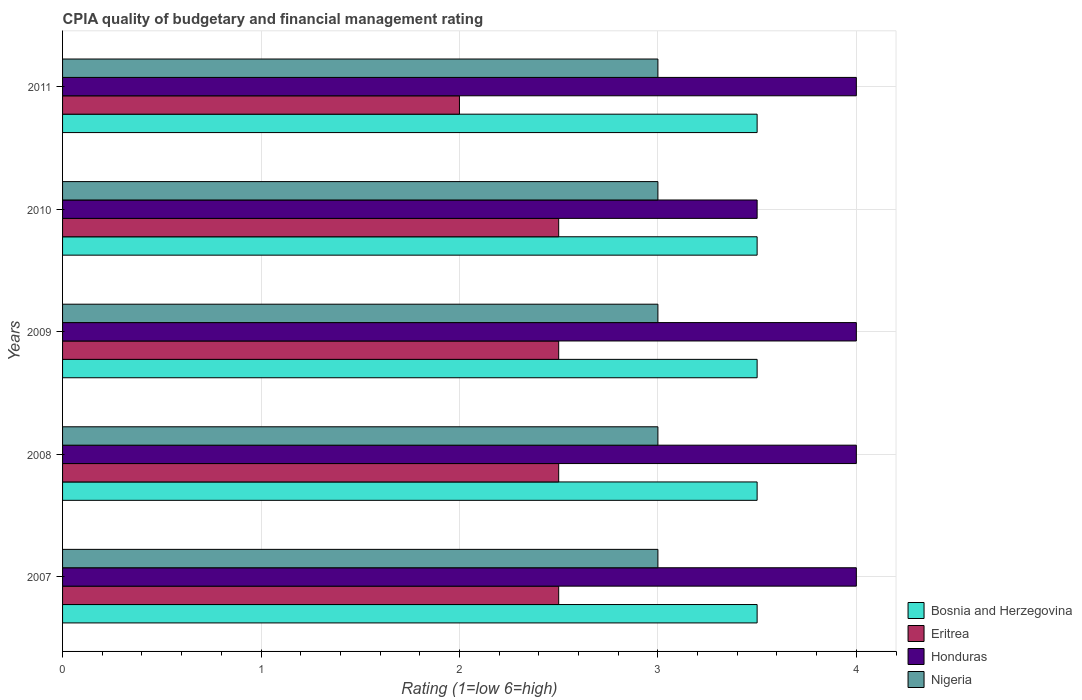Are the number of bars per tick equal to the number of legend labels?
Provide a succinct answer. Yes. How many bars are there on the 1st tick from the top?
Offer a terse response. 4. In how many cases, is the number of bars for a given year not equal to the number of legend labels?
Ensure brevity in your answer.  0. What is the CPIA rating in Honduras in 2007?
Keep it short and to the point. 4. Across all years, what is the maximum CPIA rating in Honduras?
Give a very brief answer. 4. What is the total CPIA rating in Honduras in the graph?
Keep it short and to the point. 19.5. What is the difference between the CPIA rating in Nigeria in 2009 and that in 2011?
Offer a very short reply. 0. What is the average CPIA rating in Nigeria per year?
Offer a terse response. 3. In the year 2008, what is the difference between the CPIA rating in Bosnia and Herzegovina and CPIA rating in Nigeria?
Your response must be concise. 0.5. What is the ratio of the CPIA rating in Bosnia and Herzegovina in 2007 to that in 2008?
Offer a very short reply. 1. Is the CPIA rating in Nigeria in 2007 less than that in 2008?
Make the answer very short. No. What is the difference between the highest and the second highest CPIA rating in Honduras?
Your response must be concise. 0. What is the difference between the highest and the lowest CPIA rating in Honduras?
Offer a very short reply. 0.5. In how many years, is the CPIA rating in Eritrea greater than the average CPIA rating in Eritrea taken over all years?
Offer a terse response. 4. What does the 4th bar from the top in 2011 represents?
Offer a very short reply. Bosnia and Herzegovina. What does the 4th bar from the bottom in 2007 represents?
Ensure brevity in your answer.  Nigeria. Is it the case that in every year, the sum of the CPIA rating in Eritrea and CPIA rating in Bosnia and Herzegovina is greater than the CPIA rating in Nigeria?
Your answer should be very brief. Yes. How many bars are there?
Ensure brevity in your answer.  20. Are all the bars in the graph horizontal?
Your answer should be very brief. Yes. How many years are there in the graph?
Your response must be concise. 5. What is the difference between two consecutive major ticks on the X-axis?
Ensure brevity in your answer.  1. How many legend labels are there?
Offer a very short reply. 4. How are the legend labels stacked?
Your answer should be compact. Vertical. What is the title of the graph?
Make the answer very short. CPIA quality of budgetary and financial management rating. What is the Rating (1=low 6=high) in Bosnia and Herzegovina in 2007?
Ensure brevity in your answer.  3.5. What is the Rating (1=low 6=high) in Eritrea in 2007?
Keep it short and to the point. 2.5. What is the Rating (1=low 6=high) in Nigeria in 2008?
Provide a succinct answer. 3. What is the Rating (1=low 6=high) of Bosnia and Herzegovina in 2009?
Keep it short and to the point. 3.5. What is the Rating (1=low 6=high) of Eritrea in 2009?
Give a very brief answer. 2.5. What is the Rating (1=low 6=high) of Honduras in 2009?
Make the answer very short. 4. What is the Rating (1=low 6=high) in Nigeria in 2009?
Your response must be concise. 3. What is the Rating (1=low 6=high) of Honduras in 2010?
Make the answer very short. 3.5. What is the Rating (1=low 6=high) of Nigeria in 2010?
Offer a terse response. 3. What is the Rating (1=low 6=high) of Honduras in 2011?
Your answer should be very brief. 4. What is the Rating (1=low 6=high) of Nigeria in 2011?
Offer a very short reply. 3. Across all years, what is the maximum Rating (1=low 6=high) in Nigeria?
Provide a succinct answer. 3. Across all years, what is the minimum Rating (1=low 6=high) of Eritrea?
Your answer should be very brief. 2. Across all years, what is the minimum Rating (1=low 6=high) of Honduras?
Provide a succinct answer. 3.5. Across all years, what is the minimum Rating (1=low 6=high) of Nigeria?
Give a very brief answer. 3. What is the total Rating (1=low 6=high) in Bosnia and Herzegovina in the graph?
Your answer should be compact. 17.5. What is the difference between the Rating (1=low 6=high) in Bosnia and Herzegovina in 2007 and that in 2008?
Your response must be concise. 0. What is the difference between the Rating (1=low 6=high) in Eritrea in 2007 and that in 2008?
Your answer should be very brief. 0. What is the difference between the Rating (1=low 6=high) in Bosnia and Herzegovina in 2007 and that in 2009?
Offer a very short reply. 0. What is the difference between the Rating (1=low 6=high) of Eritrea in 2007 and that in 2009?
Your answer should be compact. 0. What is the difference between the Rating (1=low 6=high) of Honduras in 2007 and that in 2009?
Provide a succinct answer. 0. What is the difference between the Rating (1=low 6=high) of Nigeria in 2007 and that in 2009?
Your answer should be very brief. 0. What is the difference between the Rating (1=low 6=high) of Eritrea in 2007 and that in 2010?
Your answer should be very brief. 0. What is the difference between the Rating (1=low 6=high) in Honduras in 2007 and that in 2011?
Offer a very short reply. 0. What is the difference between the Rating (1=low 6=high) of Eritrea in 2008 and that in 2009?
Your answer should be compact. 0. What is the difference between the Rating (1=low 6=high) of Bosnia and Herzegovina in 2008 and that in 2010?
Provide a succinct answer. 0. What is the difference between the Rating (1=low 6=high) in Eritrea in 2008 and that in 2010?
Your response must be concise. 0. What is the difference between the Rating (1=low 6=high) of Bosnia and Herzegovina in 2008 and that in 2011?
Ensure brevity in your answer.  0. What is the difference between the Rating (1=low 6=high) in Honduras in 2008 and that in 2011?
Make the answer very short. 0. What is the difference between the Rating (1=low 6=high) in Nigeria in 2008 and that in 2011?
Your answer should be very brief. 0. What is the difference between the Rating (1=low 6=high) of Eritrea in 2009 and that in 2010?
Offer a terse response. 0. What is the difference between the Rating (1=low 6=high) of Bosnia and Herzegovina in 2009 and that in 2011?
Your answer should be very brief. 0. What is the difference between the Rating (1=low 6=high) in Bosnia and Herzegovina in 2010 and that in 2011?
Your response must be concise. 0. What is the difference between the Rating (1=low 6=high) in Eritrea in 2010 and that in 2011?
Keep it short and to the point. 0.5. What is the difference between the Rating (1=low 6=high) of Nigeria in 2010 and that in 2011?
Your answer should be very brief. 0. What is the difference between the Rating (1=low 6=high) of Bosnia and Herzegovina in 2007 and the Rating (1=low 6=high) of Honduras in 2008?
Offer a terse response. -0.5. What is the difference between the Rating (1=low 6=high) of Bosnia and Herzegovina in 2007 and the Rating (1=low 6=high) of Nigeria in 2008?
Your response must be concise. 0.5. What is the difference between the Rating (1=low 6=high) of Eritrea in 2007 and the Rating (1=low 6=high) of Honduras in 2008?
Ensure brevity in your answer.  -1.5. What is the difference between the Rating (1=low 6=high) of Eritrea in 2007 and the Rating (1=low 6=high) of Nigeria in 2008?
Provide a succinct answer. -0.5. What is the difference between the Rating (1=low 6=high) of Bosnia and Herzegovina in 2007 and the Rating (1=low 6=high) of Eritrea in 2009?
Give a very brief answer. 1. What is the difference between the Rating (1=low 6=high) in Bosnia and Herzegovina in 2007 and the Rating (1=low 6=high) in Honduras in 2009?
Provide a succinct answer. -0.5. What is the difference between the Rating (1=low 6=high) of Bosnia and Herzegovina in 2007 and the Rating (1=low 6=high) of Nigeria in 2009?
Your answer should be compact. 0.5. What is the difference between the Rating (1=low 6=high) of Eritrea in 2007 and the Rating (1=low 6=high) of Nigeria in 2009?
Give a very brief answer. -0.5. What is the difference between the Rating (1=low 6=high) of Honduras in 2007 and the Rating (1=low 6=high) of Nigeria in 2009?
Offer a terse response. 1. What is the difference between the Rating (1=low 6=high) of Bosnia and Herzegovina in 2007 and the Rating (1=low 6=high) of Nigeria in 2010?
Offer a terse response. 0.5. What is the difference between the Rating (1=low 6=high) of Eritrea in 2007 and the Rating (1=low 6=high) of Honduras in 2010?
Make the answer very short. -1. What is the difference between the Rating (1=low 6=high) in Eritrea in 2007 and the Rating (1=low 6=high) in Nigeria in 2010?
Offer a very short reply. -0.5. What is the difference between the Rating (1=low 6=high) in Bosnia and Herzegovina in 2007 and the Rating (1=low 6=high) in Honduras in 2011?
Provide a short and direct response. -0.5. What is the difference between the Rating (1=low 6=high) in Bosnia and Herzegovina in 2008 and the Rating (1=low 6=high) in Honduras in 2009?
Offer a terse response. -0.5. What is the difference between the Rating (1=low 6=high) in Bosnia and Herzegovina in 2008 and the Rating (1=low 6=high) in Nigeria in 2009?
Make the answer very short. 0.5. What is the difference between the Rating (1=low 6=high) in Eritrea in 2008 and the Rating (1=low 6=high) in Honduras in 2009?
Make the answer very short. -1.5. What is the difference between the Rating (1=low 6=high) in Bosnia and Herzegovina in 2008 and the Rating (1=low 6=high) in Honduras in 2010?
Keep it short and to the point. 0. What is the difference between the Rating (1=low 6=high) in Bosnia and Herzegovina in 2008 and the Rating (1=low 6=high) in Nigeria in 2010?
Your answer should be compact. 0.5. What is the difference between the Rating (1=low 6=high) of Eritrea in 2008 and the Rating (1=low 6=high) of Honduras in 2010?
Provide a short and direct response. -1. What is the difference between the Rating (1=low 6=high) in Bosnia and Herzegovina in 2009 and the Rating (1=low 6=high) in Eritrea in 2010?
Offer a very short reply. 1. What is the difference between the Rating (1=low 6=high) of Bosnia and Herzegovina in 2009 and the Rating (1=low 6=high) of Nigeria in 2010?
Keep it short and to the point. 0.5. What is the difference between the Rating (1=low 6=high) of Eritrea in 2009 and the Rating (1=low 6=high) of Honduras in 2010?
Ensure brevity in your answer.  -1. What is the difference between the Rating (1=low 6=high) of Eritrea in 2009 and the Rating (1=low 6=high) of Nigeria in 2010?
Make the answer very short. -0.5. What is the difference between the Rating (1=low 6=high) of Honduras in 2009 and the Rating (1=low 6=high) of Nigeria in 2010?
Provide a succinct answer. 1. What is the difference between the Rating (1=low 6=high) in Bosnia and Herzegovina in 2009 and the Rating (1=low 6=high) in Eritrea in 2011?
Offer a very short reply. 1.5. What is the difference between the Rating (1=low 6=high) in Bosnia and Herzegovina in 2009 and the Rating (1=low 6=high) in Nigeria in 2011?
Give a very brief answer. 0.5. What is the difference between the Rating (1=low 6=high) in Eritrea in 2009 and the Rating (1=low 6=high) in Honduras in 2011?
Keep it short and to the point. -1.5. What is the difference between the Rating (1=low 6=high) in Bosnia and Herzegovina in 2010 and the Rating (1=low 6=high) in Nigeria in 2011?
Your response must be concise. 0.5. What is the difference between the Rating (1=low 6=high) in Eritrea in 2010 and the Rating (1=low 6=high) in Honduras in 2011?
Your response must be concise. -1.5. What is the difference between the Rating (1=low 6=high) in Eritrea in 2010 and the Rating (1=low 6=high) in Nigeria in 2011?
Keep it short and to the point. -0.5. What is the average Rating (1=low 6=high) of Eritrea per year?
Give a very brief answer. 2.4. In the year 2007, what is the difference between the Rating (1=low 6=high) in Bosnia and Herzegovina and Rating (1=low 6=high) in Honduras?
Your response must be concise. -0.5. In the year 2007, what is the difference between the Rating (1=low 6=high) in Bosnia and Herzegovina and Rating (1=low 6=high) in Nigeria?
Make the answer very short. 0.5. In the year 2007, what is the difference between the Rating (1=low 6=high) in Eritrea and Rating (1=low 6=high) in Honduras?
Give a very brief answer. -1.5. In the year 2007, what is the difference between the Rating (1=low 6=high) of Honduras and Rating (1=low 6=high) of Nigeria?
Ensure brevity in your answer.  1. In the year 2008, what is the difference between the Rating (1=low 6=high) of Bosnia and Herzegovina and Rating (1=low 6=high) of Honduras?
Offer a very short reply. -0.5. In the year 2008, what is the difference between the Rating (1=low 6=high) in Eritrea and Rating (1=low 6=high) in Honduras?
Your answer should be compact. -1.5. In the year 2009, what is the difference between the Rating (1=low 6=high) of Bosnia and Herzegovina and Rating (1=low 6=high) of Honduras?
Make the answer very short. -0.5. In the year 2009, what is the difference between the Rating (1=low 6=high) of Bosnia and Herzegovina and Rating (1=low 6=high) of Nigeria?
Offer a very short reply. 0.5. In the year 2009, what is the difference between the Rating (1=low 6=high) in Honduras and Rating (1=low 6=high) in Nigeria?
Keep it short and to the point. 1. In the year 2010, what is the difference between the Rating (1=low 6=high) in Bosnia and Herzegovina and Rating (1=low 6=high) in Nigeria?
Offer a very short reply. 0.5. In the year 2010, what is the difference between the Rating (1=low 6=high) in Eritrea and Rating (1=low 6=high) in Nigeria?
Your answer should be compact. -0.5. In the year 2010, what is the difference between the Rating (1=low 6=high) in Honduras and Rating (1=low 6=high) in Nigeria?
Provide a succinct answer. 0.5. What is the ratio of the Rating (1=low 6=high) of Honduras in 2007 to that in 2009?
Offer a terse response. 1. What is the ratio of the Rating (1=low 6=high) in Nigeria in 2007 to that in 2009?
Your answer should be compact. 1. What is the ratio of the Rating (1=low 6=high) of Honduras in 2007 to that in 2010?
Give a very brief answer. 1.14. What is the ratio of the Rating (1=low 6=high) in Eritrea in 2007 to that in 2011?
Make the answer very short. 1.25. What is the ratio of the Rating (1=low 6=high) in Honduras in 2007 to that in 2011?
Provide a short and direct response. 1. What is the ratio of the Rating (1=low 6=high) in Nigeria in 2007 to that in 2011?
Provide a short and direct response. 1. What is the ratio of the Rating (1=low 6=high) in Bosnia and Herzegovina in 2008 to that in 2009?
Your answer should be compact. 1. What is the ratio of the Rating (1=low 6=high) of Nigeria in 2008 to that in 2009?
Keep it short and to the point. 1. What is the ratio of the Rating (1=low 6=high) in Bosnia and Herzegovina in 2008 to that in 2010?
Your response must be concise. 1. What is the ratio of the Rating (1=low 6=high) in Eritrea in 2008 to that in 2010?
Offer a terse response. 1. What is the ratio of the Rating (1=low 6=high) in Honduras in 2008 to that in 2010?
Provide a succinct answer. 1.14. What is the ratio of the Rating (1=low 6=high) of Honduras in 2008 to that in 2011?
Your response must be concise. 1. What is the ratio of the Rating (1=low 6=high) in Bosnia and Herzegovina in 2009 to that in 2010?
Ensure brevity in your answer.  1. What is the ratio of the Rating (1=low 6=high) of Eritrea in 2009 to that in 2010?
Your answer should be compact. 1. What is the ratio of the Rating (1=low 6=high) of Nigeria in 2009 to that in 2010?
Offer a terse response. 1. What is the ratio of the Rating (1=low 6=high) in Bosnia and Herzegovina in 2009 to that in 2011?
Offer a terse response. 1. What is the ratio of the Rating (1=low 6=high) in Eritrea in 2009 to that in 2011?
Make the answer very short. 1.25. What is the ratio of the Rating (1=low 6=high) in Nigeria in 2009 to that in 2011?
Your response must be concise. 1. What is the ratio of the Rating (1=low 6=high) of Bosnia and Herzegovina in 2010 to that in 2011?
Keep it short and to the point. 1. What is the ratio of the Rating (1=low 6=high) of Honduras in 2010 to that in 2011?
Make the answer very short. 0.88. What is the difference between the highest and the lowest Rating (1=low 6=high) of Eritrea?
Offer a very short reply. 0.5. 